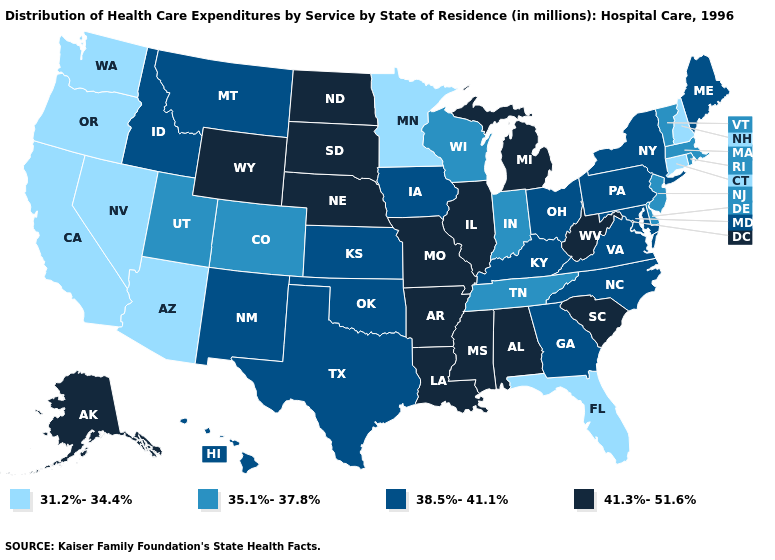How many symbols are there in the legend?
Concise answer only. 4. What is the value of Connecticut?
Short answer required. 31.2%-34.4%. What is the lowest value in the USA?
Write a very short answer. 31.2%-34.4%. What is the value of Rhode Island?
Keep it brief. 35.1%-37.8%. Does North Carolina have the same value as New York?
Answer briefly. Yes. Name the states that have a value in the range 31.2%-34.4%?
Short answer required. Arizona, California, Connecticut, Florida, Minnesota, Nevada, New Hampshire, Oregon, Washington. What is the lowest value in the USA?
Short answer required. 31.2%-34.4%. What is the value of Illinois?
Quick response, please. 41.3%-51.6%. What is the value of Texas?
Concise answer only. 38.5%-41.1%. What is the value of Illinois?
Be succinct. 41.3%-51.6%. Name the states that have a value in the range 41.3%-51.6%?
Write a very short answer. Alabama, Alaska, Arkansas, Illinois, Louisiana, Michigan, Mississippi, Missouri, Nebraska, North Dakota, South Carolina, South Dakota, West Virginia, Wyoming. What is the value of Wisconsin?
Be succinct. 35.1%-37.8%. What is the value of Michigan?
Quick response, please. 41.3%-51.6%. Does the first symbol in the legend represent the smallest category?
Give a very brief answer. Yes. What is the value of Maine?
Quick response, please. 38.5%-41.1%. 